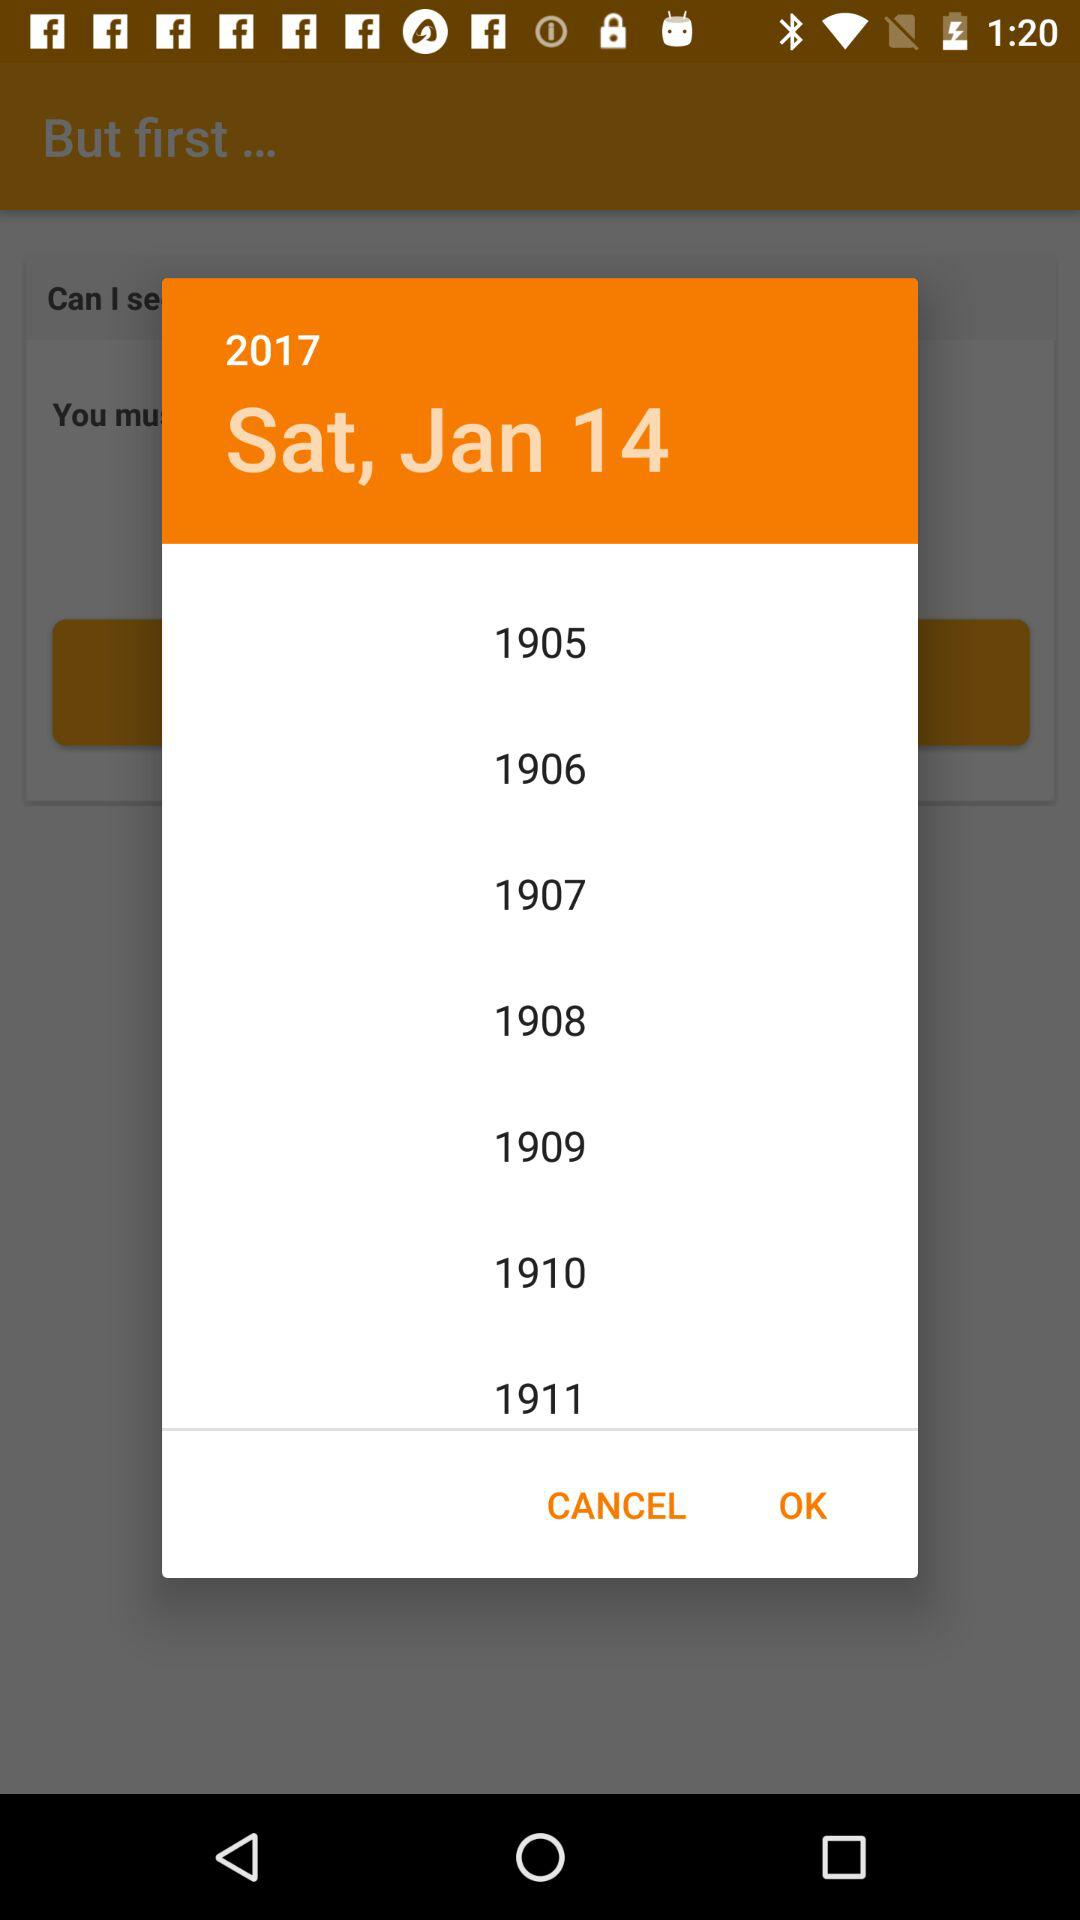Which date is selected? The selected date is Saturday, January 14, 2017. 